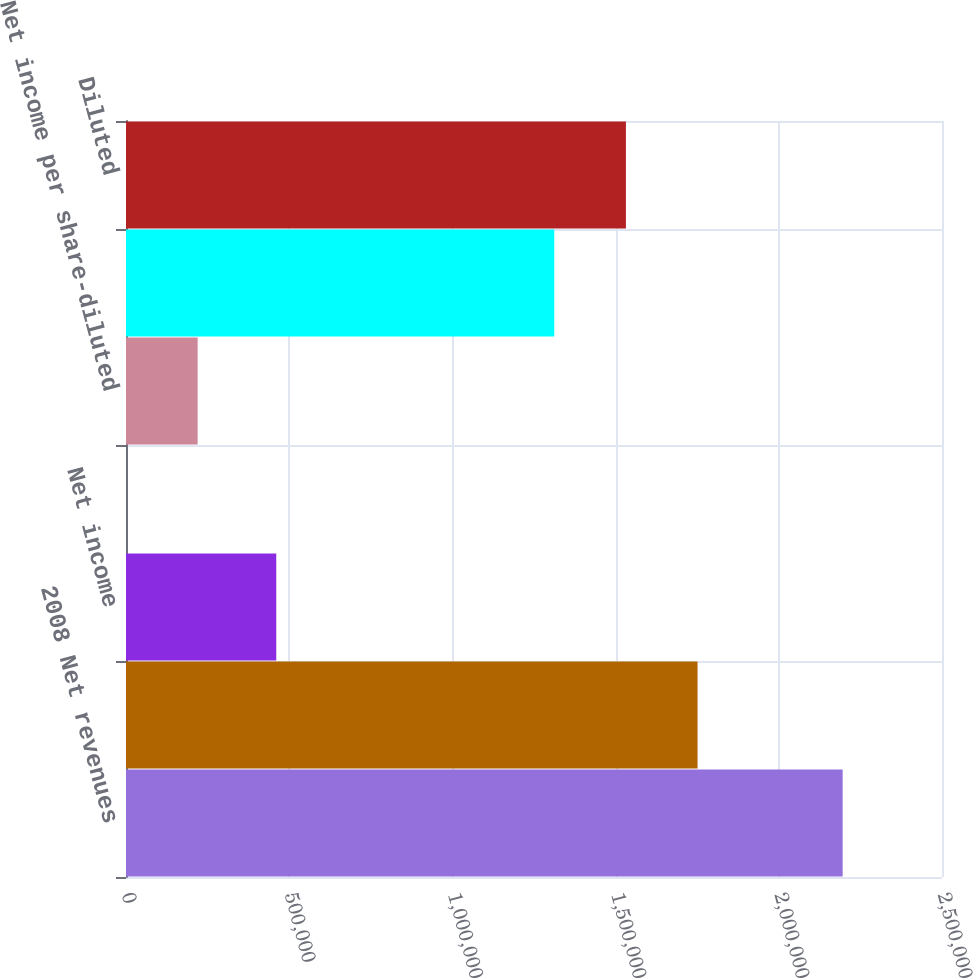<chart> <loc_0><loc_0><loc_500><loc_500><bar_chart><fcel>2008 Net revenues<fcel>Gross profit<fcel>Net income<fcel>Net income per share-basic<fcel>Net income per share-diluted<fcel>Basic<fcel>Diluted<nl><fcel>2.19566e+06<fcel>1.75114e+06<fcel>460345<fcel>0.35<fcel>219566<fcel>1.31201e+06<fcel>1.53157e+06<nl></chart> 